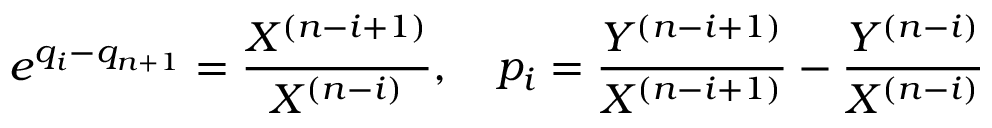Convert formula to latex. <formula><loc_0><loc_0><loc_500><loc_500>e ^ { q _ { i } - q _ { n + 1 } } = { \frac { X ^ { ( n - i + 1 ) } } { X ^ { ( n - i ) } } } , \quad p _ { i } = { \frac { Y ^ { ( n - i + 1 ) } } { X ^ { ( n - i + 1 ) } } } - { \frac { Y ^ { ( n - i ) } } { X ^ { ( n - i ) } } }</formula> 